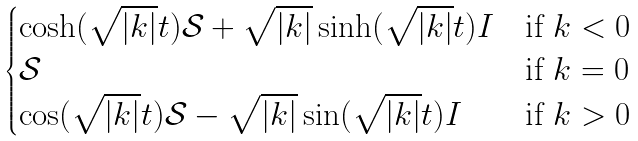Convert formula to latex. <formula><loc_0><loc_0><loc_500><loc_500>\begin{cases} \cosh ( \sqrt { | k | } t ) \mathcal { S } + \sqrt { | k | } \sinh ( \sqrt { | k | } t ) I & \text {if } k < 0 \\ \mathcal { S } & \text {if } k = 0 \\ \cos ( \sqrt { | k | } t ) \mathcal { S } - \sqrt { | k | } \sin ( \sqrt { | k | } t ) I & \text {if } k > 0 \end{cases}</formula> 